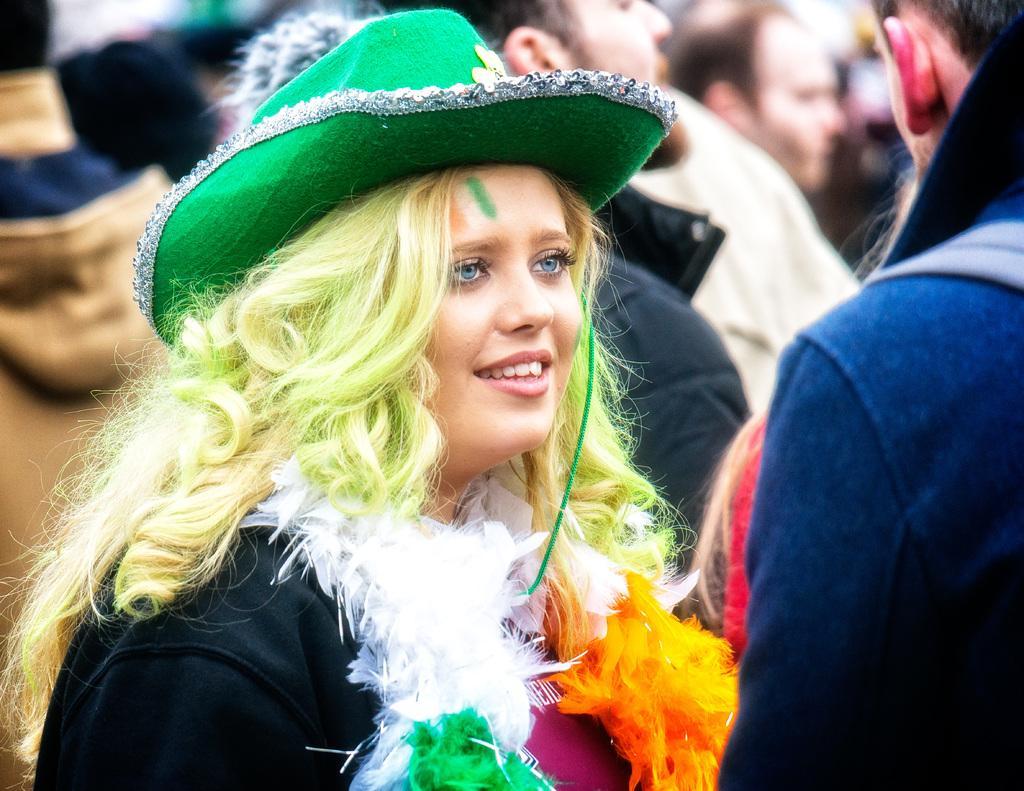How would you summarize this image in a sentence or two? In the picture we can see a woman with a costume and green hat and colored hair and around her we can see some people are standing. 